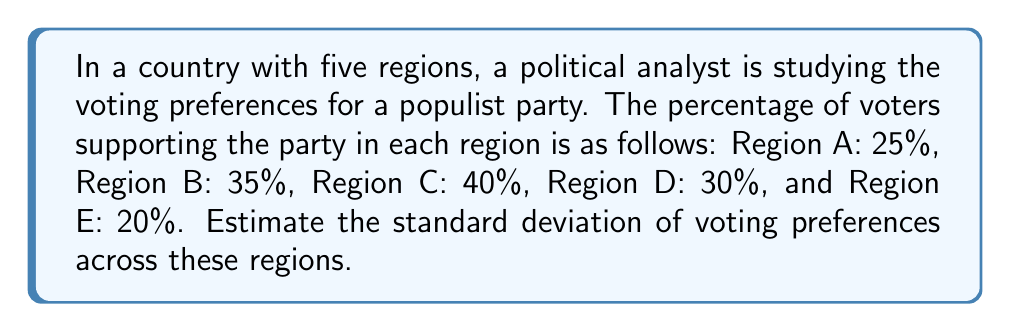Provide a solution to this math problem. To calculate the standard deviation of voting preferences, we'll follow these steps:

1. Calculate the mean (average) of the voting percentages:
   $\mu = \frac{25 + 35 + 40 + 30 + 20}{5} = 30\%$

2. Calculate the squared differences from the mean for each region:
   Region A: $(25 - 30)^2 = (-5)^2 = 25$
   Region B: $(35 - 30)^2 = (5)^2 = 25$
   Region C: $(40 - 30)^2 = (10)^2 = 100$
   Region D: $(30 - 30)^2 = (0)^2 = 0$
   Region E: $(20 - 30)^2 = (-10)^2 = 100$

3. Calculate the variance by taking the average of these squared differences:
   $\sigma^2 = \frac{25 + 25 + 100 + 0 + 100}{5} = 50$

4. Calculate the standard deviation by taking the square root of the variance:
   $\sigma = \sqrt{50} = 5\sqrt{2} \approx 7.07$

The formula for standard deviation is:

$$\sigma = \sqrt{\frac{\sum_{i=1}^{n} (x_i - \mu)^2}{n}}$$

where $x_i$ are the individual values, $\mu$ is the mean, and $n$ is the number of values.
Answer: The estimated standard deviation of voting preferences across the five regions is $5\sqrt{2} \approx 7.07\%$. 